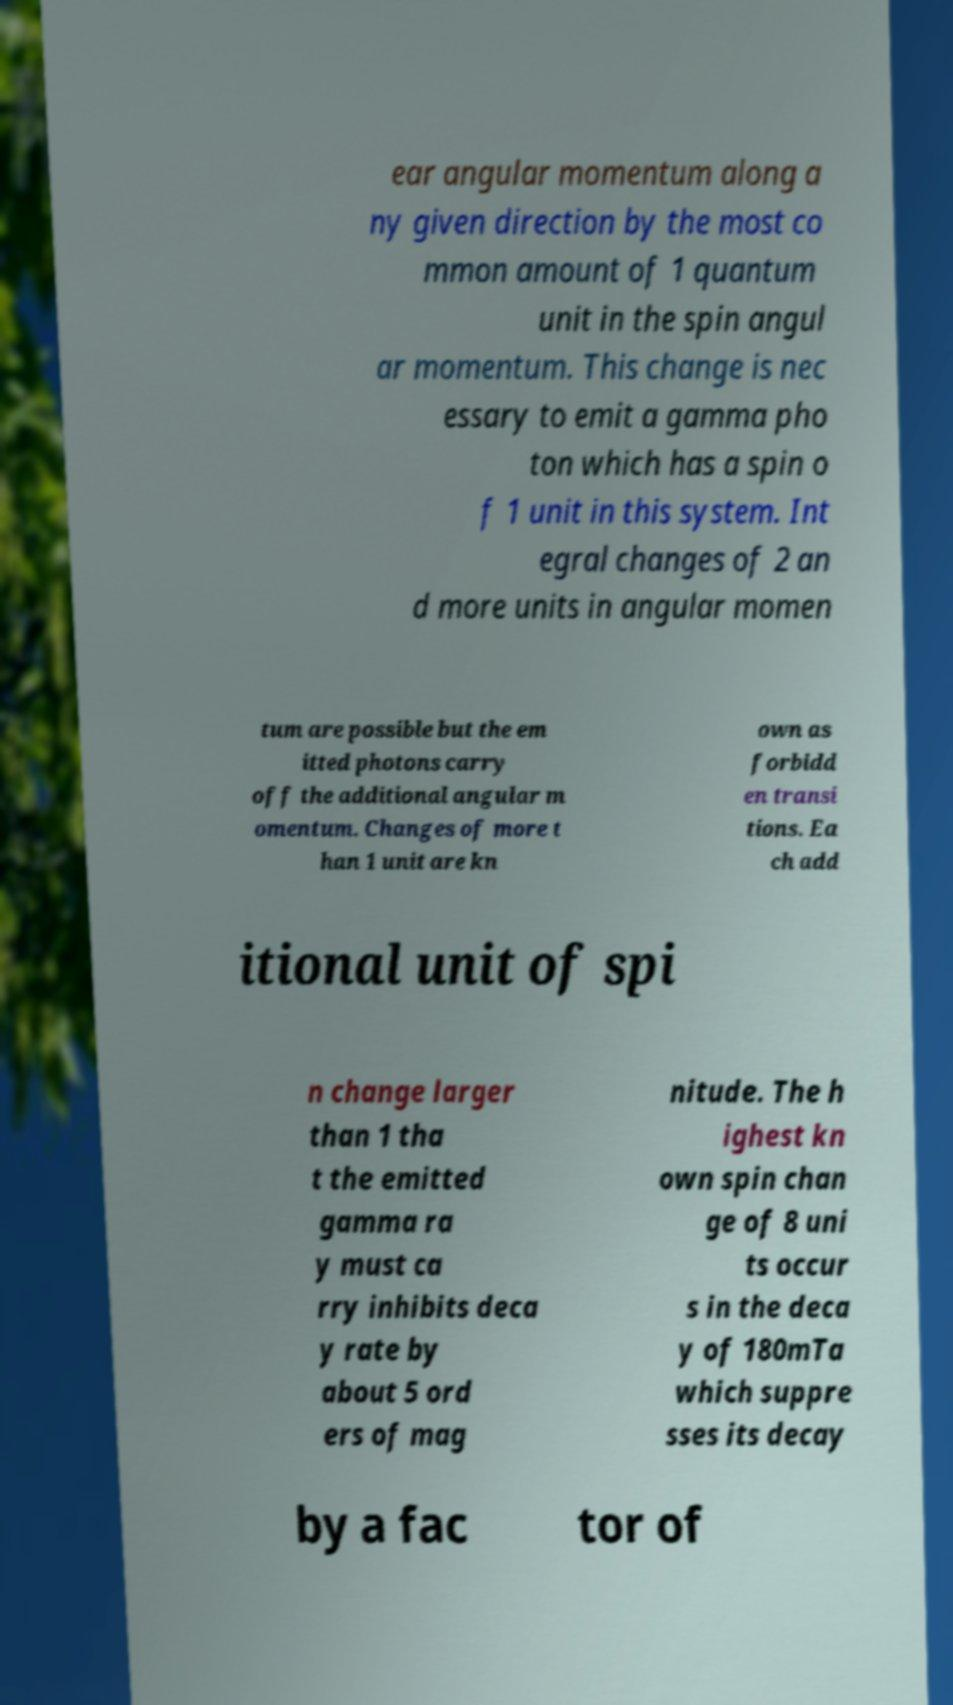Please identify and transcribe the text found in this image. ear angular momentum along a ny given direction by the most co mmon amount of 1 quantum unit in the spin angul ar momentum. This change is nec essary to emit a gamma pho ton which has a spin o f 1 unit in this system. Int egral changes of 2 an d more units in angular momen tum are possible but the em itted photons carry off the additional angular m omentum. Changes of more t han 1 unit are kn own as forbidd en transi tions. Ea ch add itional unit of spi n change larger than 1 tha t the emitted gamma ra y must ca rry inhibits deca y rate by about 5 ord ers of mag nitude. The h ighest kn own spin chan ge of 8 uni ts occur s in the deca y of 180mTa which suppre sses its decay by a fac tor of 